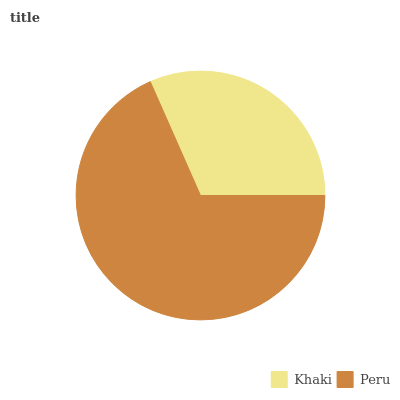Is Khaki the minimum?
Answer yes or no. Yes. Is Peru the maximum?
Answer yes or no. Yes. Is Peru the minimum?
Answer yes or no. No. Is Peru greater than Khaki?
Answer yes or no. Yes. Is Khaki less than Peru?
Answer yes or no. Yes. Is Khaki greater than Peru?
Answer yes or no. No. Is Peru less than Khaki?
Answer yes or no. No. Is Peru the high median?
Answer yes or no. Yes. Is Khaki the low median?
Answer yes or no. Yes. Is Khaki the high median?
Answer yes or no. No. Is Peru the low median?
Answer yes or no. No. 